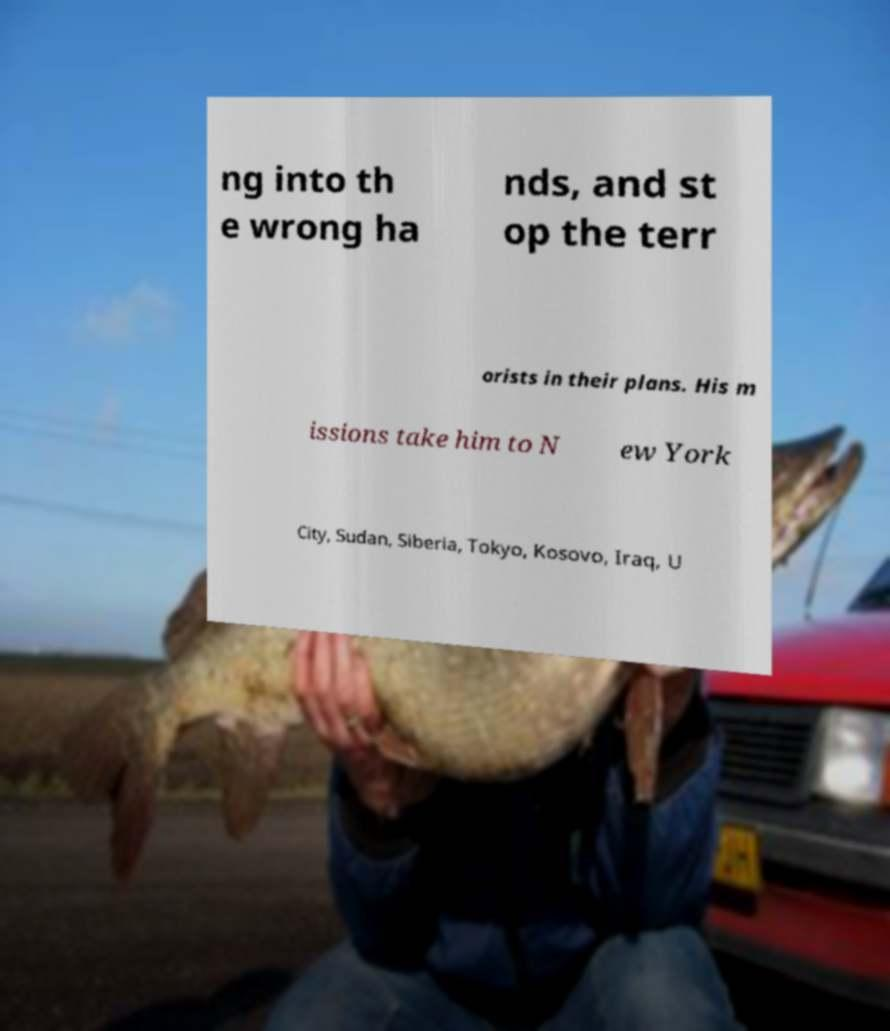Could you assist in decoding the text presented in this image and type it out clearly? ng into th e wrong ha nds, and st op the terr orists in their plans. His m issions take him to N ew York City, Sudan, Siberia, Tokyo, Kosovo, Iraq, U 